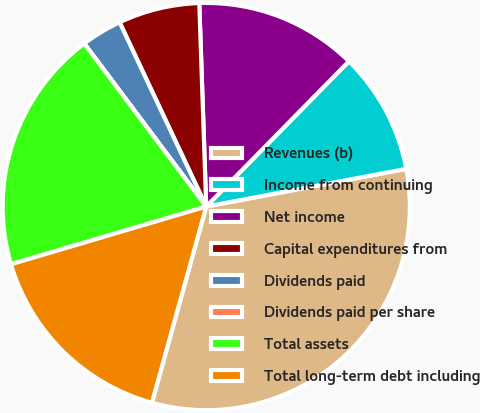Convert chart to OTSL. <chart><loc_0><loc_0><loc_500><loc_500><pie_chart><fcel>Revenues (b)<fcel>Income from continuing<fcel>Net income<fcel>Capital expenditures from<fcel>Dividends paid<fcel>Dividends paid per share<fcel>Total assets<fcel>Total long-term debt including<nl><fcel>32.26%<fcel>9.68%<fcel>12.9%<fcel>6.45%<fcel>3.23%<fcel>0.0%<fcel>19.35%<fcel>16.13%<nl></chart> 